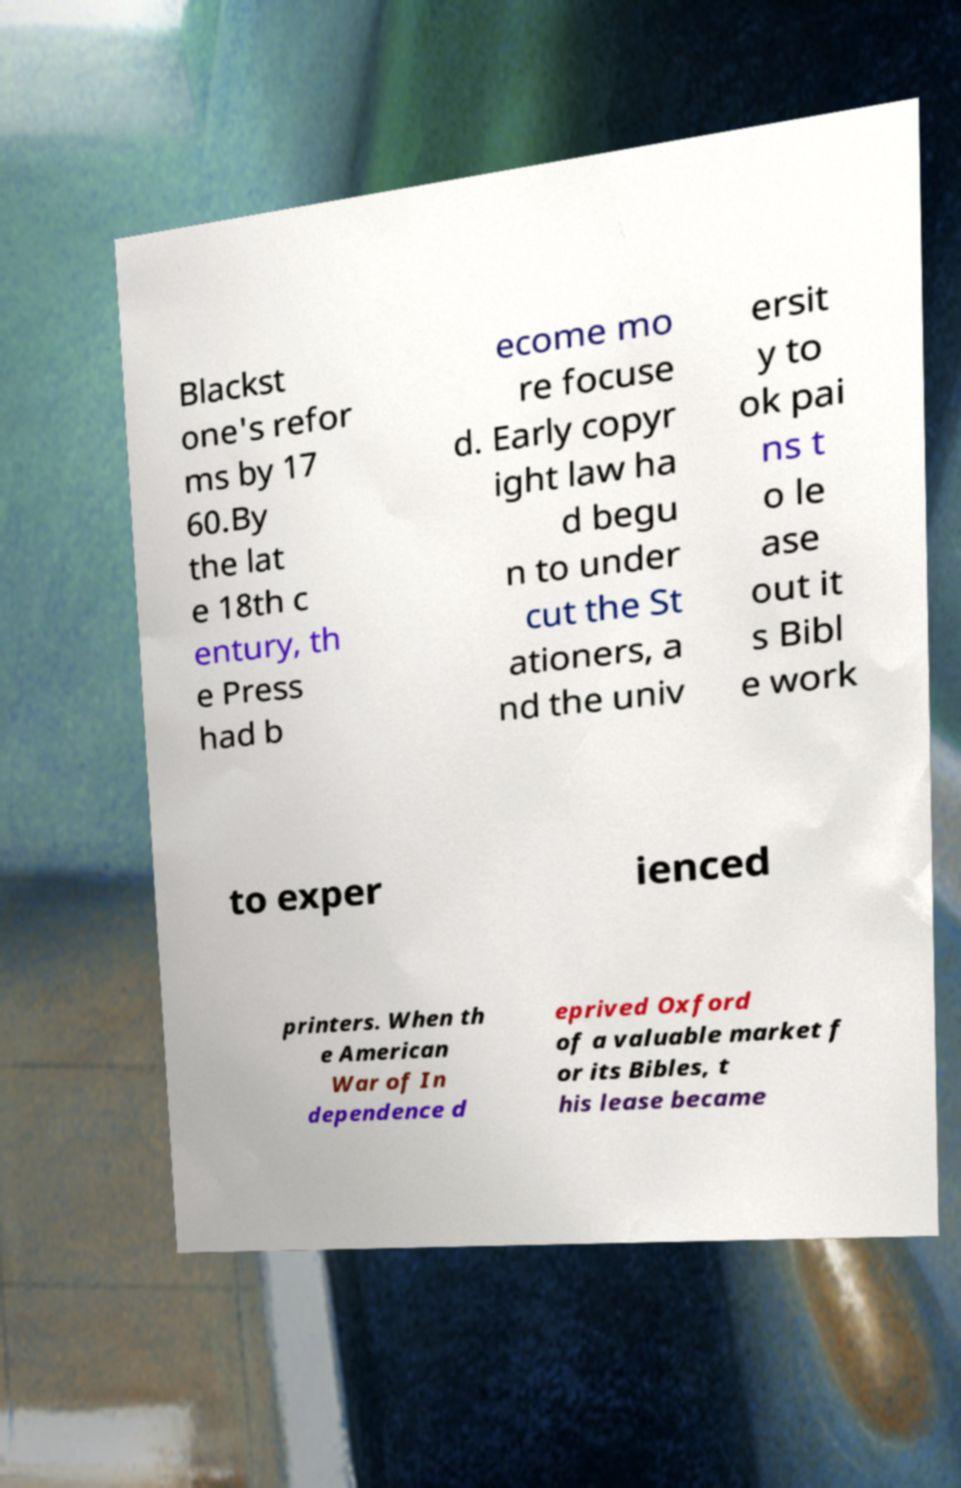There's text embedded in this image that I need extracted. Can you transcribe it verbatim? Blackst one's refor ms by 17 60.By the lat e 18th c entury, th e Press had b ecome mo re focuse d. Early copyr ight law ha d begu n to under cut the St ationers, a nd the univ ersit y to ok pai ns t o le ase out it s Bibl e work to exper ienced printers. When th e American War of In dependence d eprived Oxford of a valuable market f or its Bibles, t his lease became 